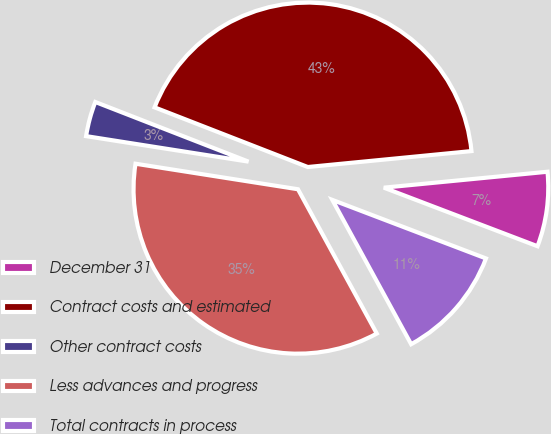Convert chart to OTSL. <chart><loc_0><loc_0><loc_500><loc_500><pie_chart><fcel>December 31<fcel>Contract costs and estimated<fcel>Other contract costs<fcel>Less advances and progress<fcel>Total contracts in process<nl><fcel>7.34%<fcel>42.55%<fcel>3.43%<fcel>35.44%<fcel>11.25%<nl></chart> 